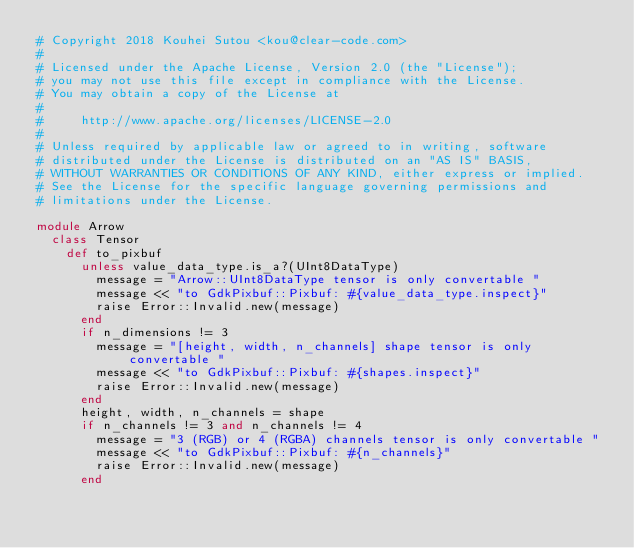<code> <loc_0><loc_0><loc_500><loc_500><_Ruby_># Copyright 2018 Kouhei Sutou <kou@clear-code.com>
#
# Licensed under the Apache License, Version 2.0 (the "License");
# you may not use this file except in compliance with the License.
# You may obtain a copy of the License at
#
#     http://www.apache.org/licenses/LICENSE-2.0
#
# Unless required by applicable law or agreed to in writing, software
# distributed under the License is distributed on an "AS IS" BASIS,
# WITHOUT WARRANTIES OR CONDITIONS OF ANY KIND, either express or implied.
# See the License for the specific language governing permissions and
# limitations under the License.

module Arrow
  class Tensor
    def to_pixbuf
      unless value_data_type.is_a?(UInt8DataType)
        message = "Arrow::UInt8DataType tensor is only convertable "
        message << "to GdkPixbuf::Pixbuf: #{value_data_type.inspect}"
        raise Error::Invalid.new(message)
      end
      if n_dimensions != 3
        message = "[height, width, n_channels] shape tensor is only convertable "
        message << "to GdkPixbuf::Pixbuf: #{shapes.inspect}"
        raise Error::Invalid.new(message)
      end
      height, width, n_channels = shape
      if n_channels != 3 and n_channels != 4
        message = "3 (RGB) or 4 (RGBA) channels tensor is only convertable "
        message << "to GdkPixbuf::Pixbuf: #{n_channels}"
        raise Error::Invalid.new(message)
      end</code> 